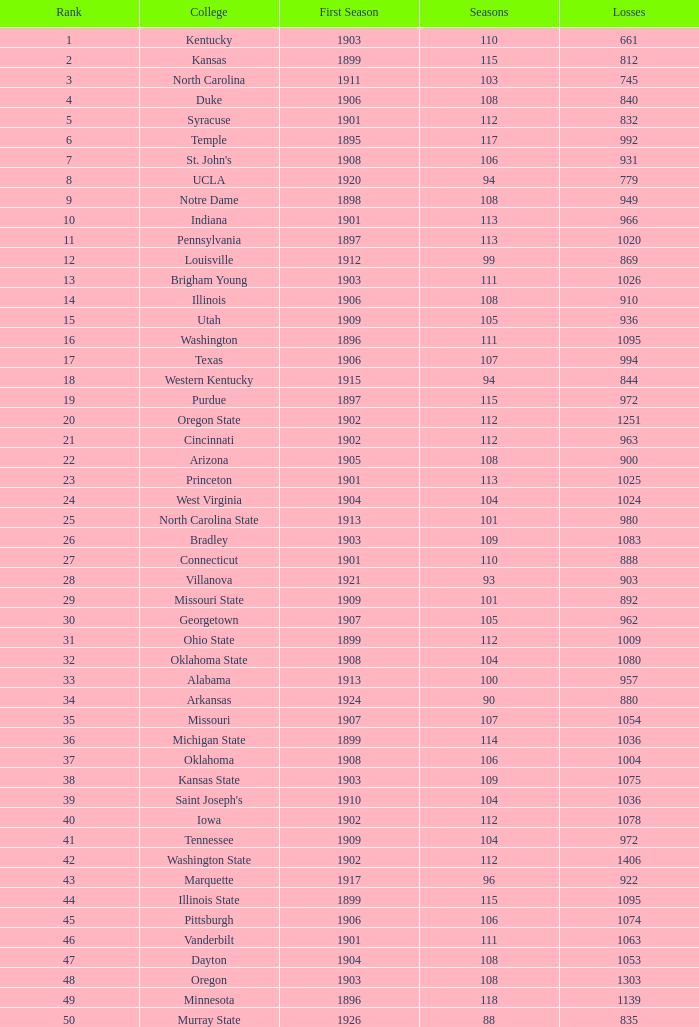What is the total of First Season games with 1537 Wins and a Season greater than 109? None. 